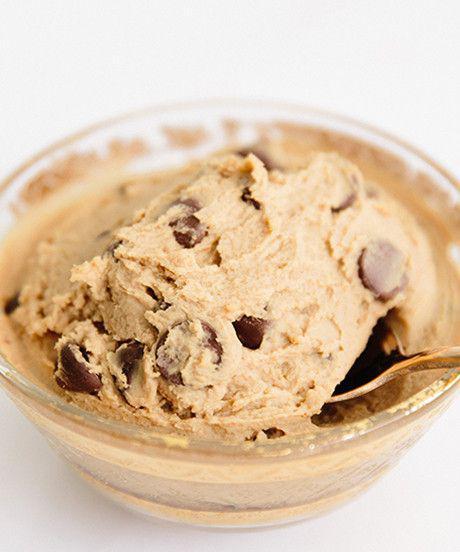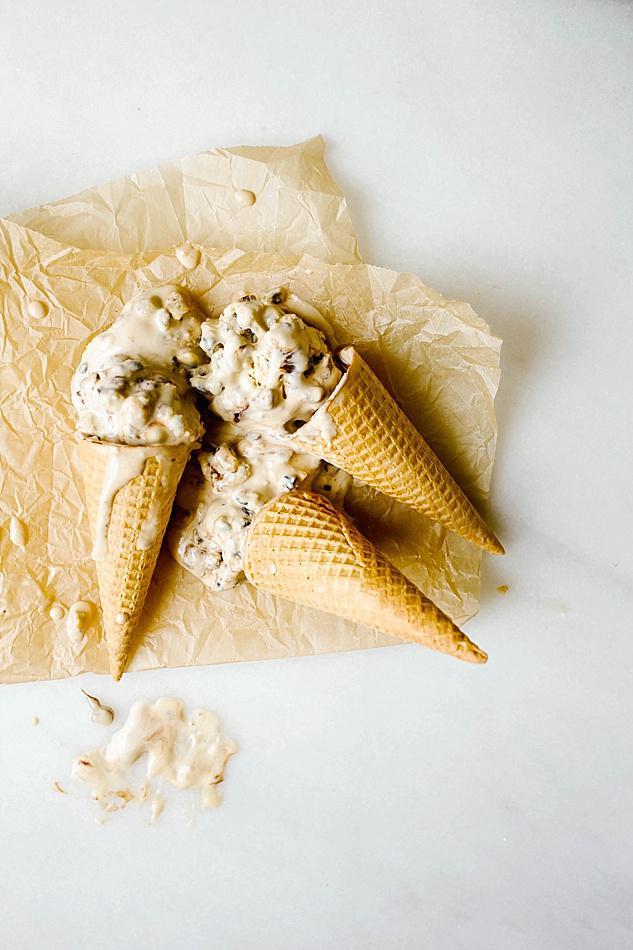The first image is the image on the left, the second image is the image on the right. Evaluate the accuracy of this statement regarding the images: "There is at least one human hand holding a spoon.". Is it true? Answer yes or no. No. The first image is the image on the left, the second image is the image on the right. Given the left and right images, does the statement "There is a spoon filled with cookie dough in the center of each image." hold true? Answer yes or no. No. 